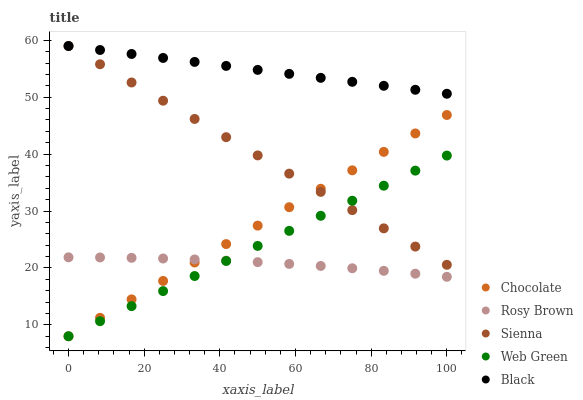Does Rosy Brown have the minimum area under the curve?
Answer yes or no. Yes. Does Black have the maximum area under the curve?
Answer yes or no. Yes. Does Black have the minimum area under the curve?
Answer yes or no. No. Does Rosy Brown have the maximum area under the curve?
Answer yes or no. No. Is Chocolate the smoothest?
Answer yes or no. Yes. Is Rosy Brown the roughest?
Answer yes or no. Yes. Is Black the smoothest?
Answer yes or no. No. Is Black the roughest?
Answer yes or no. No. Does Web Green have the lowest value?
Answer yes or no. Yes. Does Rosy Brown have the lowest value?
Answer yes or no. No. Does Black have the highest value?
Answer yes or no. Yes. Does Rosy Brown have the highest value?
Answer yes or no. No. Is Rosy Brown less than Black?
Answer yes or no. Yes. Is Black greater than Rosy Brown?
Answer yes or no. Yes. Does Rosy Brown intersect Web Green?
Answer yes or no. Yes. Is Rosy Brown less than Web Green?
Answer yes or no. No. Is Rosy Brown greater than Web Green?
Answer yes or no. No. Does Rosy Brown intersect Black?
Answer yes or no. No. 